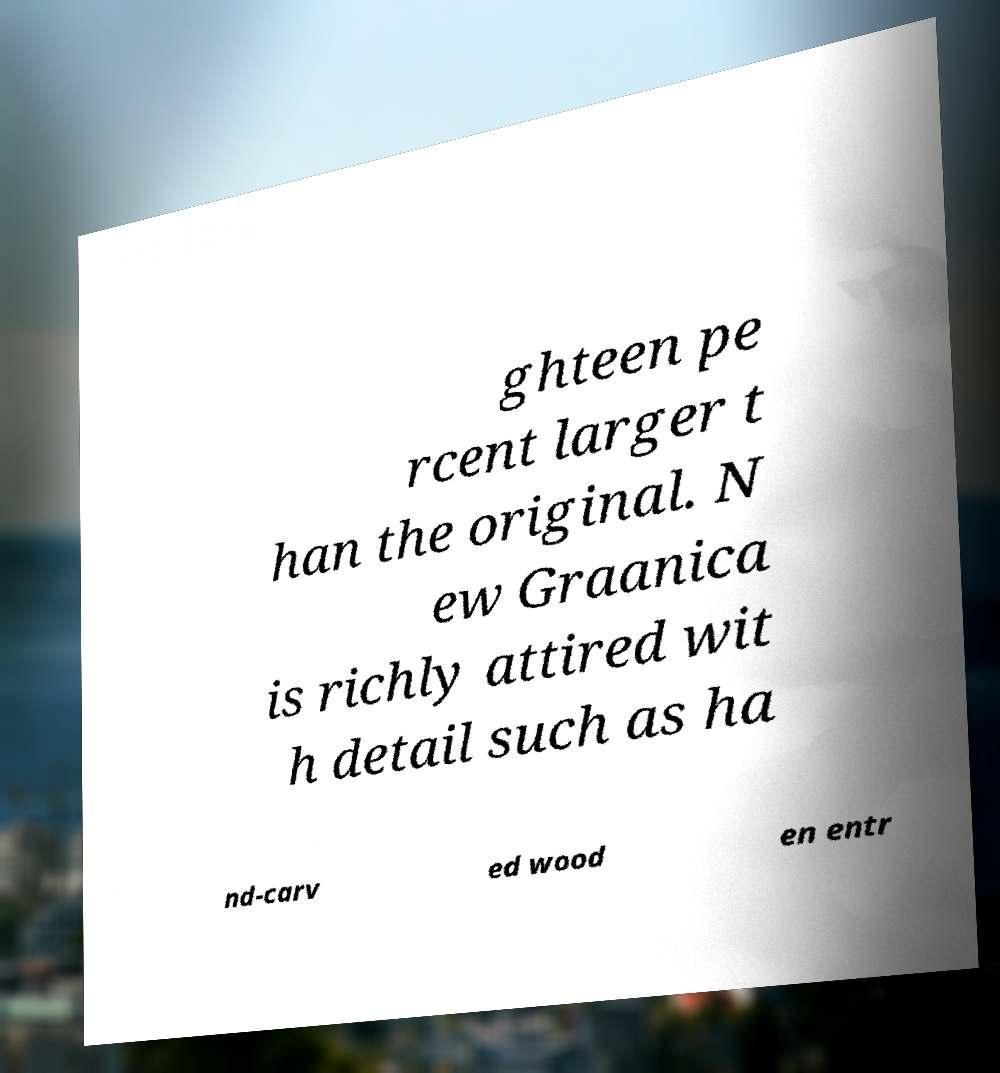Could you extract and type out the text from this image? ghteen pe rcent larger t han the original. N ew Graanica is richly attired wit h detail such as ha nd-carv ed wood en entr 